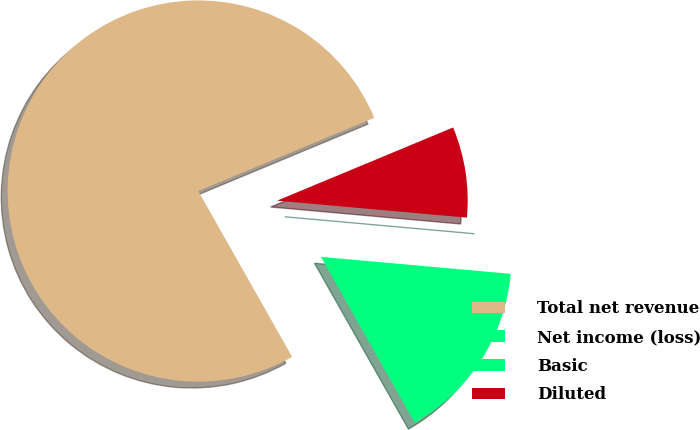<chart> <loc_0><loc_0><loc_500><loc_500><pie_chart><fcel>Total net revenue<fcel>Net income (loss)<fcel>Basic<fcel>Diluted<nl><fcel>76.92%<fcel>15.38%<fcel>0.0%<fcel>7.69%<nl></chart> 